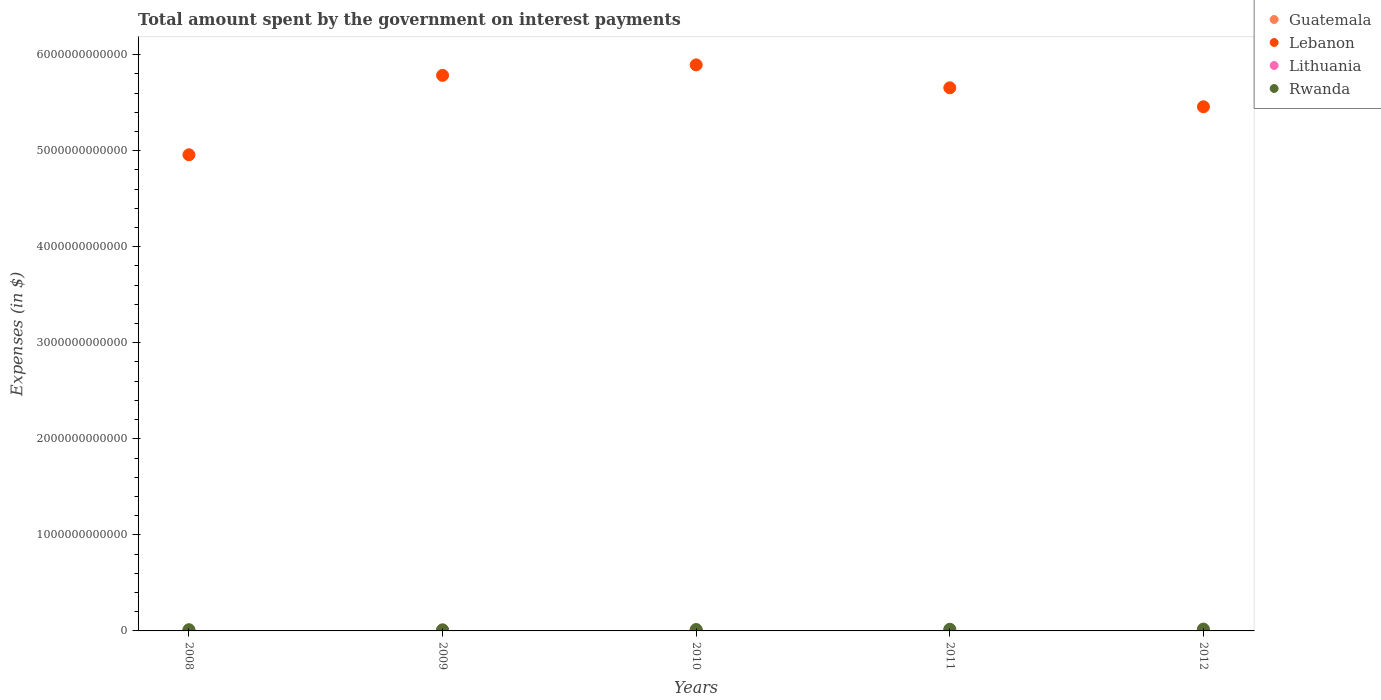How many different coloured dotlines are there?
Your response must be concise. 4. What is the amount spent on interest payments by the government in Guatemala in 2012?
Make the answer very short. 5.89e+09. Across all years, what is the maximum amount spent on interest payments by the government in Lebanon?
Provide a succinct answer. 5.89e+12. Across all years, what is the minimum amount spent on interest payments by the government in Lithuania?
Offer a terse response. 7.02e+08. In which year was the amount spent on interest payments by the government in Rwanda minimum?
Your response must be concise. 2009. What is the total amount spent on interest payments by the government in Lithuania in the graph?
Your response must be concise. 7.79e+09. What is the difference between the amount spent on interest payments by the government in Guatemala in 2010 and that in 2011?
Your answer should be compact. -5.17e+08. What is the difference between the amount spent on interest payments by the government in Guatemala in 2009 and the amount spent on interest payments by the government in Lebanon in 2010?
Your response must be concise. -5.89e+12. What is the average amount spent on interest payments by the government in Guatemala per year?
Offer a terse response. 4.87e+09. In the year 2011, what is the difference between the amount spent on interest payments by the government in Rwanda and amount spent on interest payments by the government in Lithuania?
Offer a very short reply. 1.53e+1. In how many years, is the amount spent on interest payments by the government in Rwanda greater than 3400000000000 $?
Provide a succinct answer. 0. What is the ratio of the amount spent on interest payments by the government in Lithuania in 2010 to that in 2012?
Make the answer very short. 0.83. Is the difference between the amount spent on interest payments by the government in Rwanda in 2008 and 2012 greater than the difference between the amount spent on interest payments by the government in Lithuania in 2008 and 2012?
Provide a short and direct response. No. What is the difference between the highest and the second highest amount spent on interest payments by the government in Rwanda?
Keep it short and to the point. 1.75e+09. What is the difference between the highest and the lowest amount spent on interest payments by the government in Lithuania?
Your answer should be compact. 1.46e+09. Is the sum of the amount spent on interest payments by the government in Rwanda in 2009 and 2011 greater than the maximum amount spent on interest payments by the government in Lithuania across all years?
Your answer should be very brief. Yes. Does the amount spent on interest payments by the government in Rwanda monotonically increase over the years?
Give a very brief answer. No. What is the difference between two consecutive major ticks on the Y-axis?
Your response must be concise. 1.00e+12. Does the graph contain grids?
Your response must be concise. No. How many legend labels are there?
Your response must be concise. 4. What is the title of the graph?
Your response must be concise. Total amount spent by the government on interest payments. What is the label or title of the X-axis?
Your answer should be compact. Years. What is the label or title of the Y-axis?
Your answer should be compact. Expenses (in $). What is the Expenses (in $) in Guatemala in 2008?
Your answer should be compact. 3.96e+09. What is the Expenses (in $) of Lebanon in 2008?
Your response must be concise. 4.96e+12. What is the Expenses (in $) in Lithuania in 2008?
Keep it short and to the point. 7.02e+08. What is the Expenses (in $) in Rwanda in 2008?
Make the answer very short. 1.26e+1. What is the Expenses (in $) of Guatemala in 2009?
Your answer should be compact. 4.30e+09. What is the Expenses (in $) in Lebanon in 2009?
Your response must be concise. 5.78e+12. What is the Expenses (in $) of Lithuania in 2009?
Provide a short and direct response. 1.13e+09. What is the Expenses (in $) of Rwanda in 2009?
Provide a short and direct response. 1.14e+1. What is the Expenses (in $) of Guatemala in 2010?
Ensure brevity in your answer.  4.83e+09. What is the Expenses (in $) in Lebanon in 2010?
Give a very brief answer. 5.89e+12. What is the Expenses (in $) of Lithuania in 2010?
Offer a very short reply. 1.79e+09. What is the Expenses (in $) of Rwanda in 2010?
Make the answer very short. 1.47e+1. What is the Expenses (in $) of Guatemala in 2011?
Provide a succinct answer. 5.35e+09. What is the Expenses (in $) of Lebanon in 2011?
Offer a terse response. 5.65e+12. What is the Expenses (in $) in Lithuania in 2011?
Your answer should be very brief. 2.01e+09. What is the Expenses (in $) in Rwanda in 2011?
Give a very brief answer. 1.74e+1. What is the Expenses (in $) of Guatemala in 2012?
Your answer should be compact. 5.89e+09. What is the Expenses (in $) of Lebanon in 2012?
Give a very brief answer. 5.46e+12. What is the Expenses (in $) of Lithuania in 2012?
Your answer should be very brief. 2.16e+09. What is the Expenses (in $) of Rwanda in 2012?
Your answer should be very brief. 1.91e+1. Across all years, what is the maximum Expenses (in $) in Guatemala?
Offer a very short reply. 5.89e+09. Across all years, what is the maximum Expenses (in $) in Lebanon?
Give a very brief answer. 5.89e+12. Across all years, what is the maximum Expenses (in $) in Lithuania?
Your response must be concise. 2.16e+09. Across all years, what is the maximum Expenses (in $) in Rwanda?
Your answer should be compact. 1.91e+1. Across all years, what is the minimum Expenses (in $) in Guatemala?
Make the answer very short. 3.96e+09. Across all years, what is the minimum Expenses (in $) in Lebanon?
Give a very brief answer. 4.96e+12. Across all years, what is the minimum Expenses (in $) of Lithuania?
Provide a succinct answer. 7.02e+08. Across all years, what is the minimum Expenses (in $) of Rwanda?
Your answer should be compact. 1.14e+1. What is the total Expenses (in $) in Guatemala in the graph?
Offer a very short reply. 2.43e+1. What is the total Expenses (in $) of Lebanon in the graph?
Offer a terse response. 2.77e+13. What is the total Expenses (in $) of Lithuania in the graph?
Your answer should be compact. 7.79e+09. What is the total Expenses (in $) in Rwanda in the graph?
Provide a short and direct response. 7.52e+1. What is the difference between the Expenses (in $) of Guatemala in 2008 and that in 2009?
Your answer should be compact. -3.34e+08. What is the difference between the Expenses (in $) of Lebanon in 2008 and that in 2009?
Offer a terse response. -8.27e+11. What is the difference between the Expenses (in $) in Lithuania in 2008 and that in 2009?
Your answer should be very brief. -4.26e+08. What is the difference between the Expenses (in $) of Rwanda in 2008 and that in 2009?
Provide a short and direct response. 1.20e+09. What is the difference between the Expenses (in $) in Guatemala in 2008 and that in 2010?
Ensure brevity in your answer.  -8.70e+08. What is the difference between the Expenses (in $) of Lebanon in 2008 and that in 2010?
Ensure brevity in your answer.  -9.36e+11. What is the difference between the Expenses (in $) of Lithuania in 2008 and that in 2010?
Make the answer very short. -1.09e+09. What is the difference between the Expenses (in $) in Rwanda in 2008 and that in 2010?
Provide a short and direct response. -2.06e+09. What is the difference between the Expenses (in $) of Guatemala in 2008 and that in 2011?
Your answer should be very brief. -1.39e+09. What is the difference between the Expenses (in $) in Lebanon in 2008 and that in 2011?
Your answer should be compact. -6.97e+11. What is the difference between the Expenses (in $) in Lithuania in 2008 and that in 2011?
Your response must be concise. -1.31e+09. What is the difference between the Expenses (in $) in Rwanda in 2008 and that in 2011?
Your answer should be compact. -4.74e+09. What is the difference between the Expenses (in $) in Guatemala in 2008 and that in 2012?
Your answer should be very brief. -1.93e+09. What is the difference between the Expenses (in $) in Lebanon in 2008 and that in 2012?
Your answer should be compact. -5.00e+11. What is the difference between the Expenses (in $) in Lithuania in 2008 and that in 2012?
Provide a short and direct response. -1.46e+09. What is the difference between the Expenses (in $) of Rwanda in 2008 and that in 2012?
Provide a short and direct response. -6.49e+09. What is the difference between the Expenses (in $) of Guatemala in 2009 and that in 2010?
Your response must be concise. -5.37e+08. What is the difference between the Expenses (in $) in Lebanon in 2009 and that in 2010?
Give a very brief answer. -1.09e+11. What is the difference between the Expenses (in $) in Lithuania in 2009 and that in 2010?
Give a very brief answer. -6.61e+08. What is the difference between the Expenses (in $) in Rwanda in 2009 and that in 2010?
Keep it short and to the point. -3.26e+09. What is the difference between the Expenses (in $) of Guatemala in 2009 and that in 2011?
Make the answer very short. -1.05e+09. What is the difference between the Expenses (in $) of Lebanon in 2009 and that in 2011?
Provide a succinct answer. 1.29e+11. What is the difference between the Expenses (in $) of Lithuania in 2009 and that in 2011?
Keep it short and to the point. -8.82e+08. What is the difference between the Expenses (in $) of Rwanda in 2009 and that in 2011?
Offer a very short reply. -5.94e+09. What is the difference between the Expenses (in $) in Guatemala in 2009 and that in 2012?
Your answer should be very brief. -1.60e+09. What is the difference between the Expenses (in $) of Lebanon in 2009 and that in 2012?
Your response must be concise. 3.27e+11. What is the difference between the Expenses (in $) of Lithuania in 2009 and that in 2012?
Your answer should be compact. -1.03e+09. What is the difference between the Expenses (in $) of Rwanda in 2009 and that in 2012?
Provide a short and direct response. -7.69e+09. What is the difference between the Expenses (in $) of Guatemala in 2010 and that in 2011?
Provide a short and direct response. -5.17e+08. What is the difference between the Expenses (in $) in Lebanon in 2010 and that in 2011?
Provide a short and direct response. 2.38e+11. What is the difference between the Expenses (in $) in Lithuania in 2010 and that in 2011?
Give a very brief answer. -2.20e+08. What is the difference between the Expenses (in $) in Rwanda in 2010 and that in 2011?
Offer a very short reply. -2.68e+09. What is the difference between the Expenses (in $) in Guatemala in 2010 and that in 2012?
Offer a very short reply. -1.06e+09. What is the difference between the Expenses (in $) of Lebanon in 2010 and that in 2012?
Keep it short and to the point. 4.36e+11. What is the difference between the Expenses (in $) in Lithuania in 2010 and that in 2012?
Provide a succinct answer. -3.69e+08. What is the difference between the Expenses (in $) of Rwanda in 2010 and that in 2012?
Your answer should be compact. -4.42e+09. What is the difference between the Expenses (in $) of Guatemala in 2011 and that in 2012?
Make the answer very short. -5.45e+08. What is the difference between the Expenses (in $) of Lebanon in 2011 and that in 2012?
Offer a very short reply. 1.98e+11. What is the difference between the Expenses (in $) of Lithuania in 2011 and that in 2012?
Offer a terse response. -1.48e+08. What is the difference between the Expenses (in $) in Rwanda in 2011 and that in 2012?
Provide a short and direct response. -1.75e+09. What is the difference between the Expenses (in $) in Guatemala in 2008 and the Expenses (in $) in Lebanon in 2009?
Your answer should be very brief. -5.78e+12. What is the difference between the Expenses (in $) in Guatemala in 2008 and the Expenses (in $) in Lithuania in 2009?
Give a very brief answer. 2.83e+09. What is the difference between the Expenses (in $) in Guatemala in 2008 and the Expenses (in $) in Rwanda in 2009?
Offer a very short reply. -7.45e+09. What is the difference between the Expenses (in $) in Lebanon in 2008 and the Expenses (in $) in Lithuania in 2009?
Offer a very short reply. 4.96e+12. What is the difference between the Expenses (in $) of Lebanon in 2008 and the Expenses (in $) of Rwanda in 2009?
Give a very brief answer. 4.95e+12. What is the difference between the Expenses (in $) in Lithuania in 2008 and the Expenses (in $) in Rwanda in 2009?
Give a very brief answer. -1.07e+1. What is the difference between the Expenses (in $) of Guatemala in 2008 and the Expenses (in $) of Lebanon in 2010?
Ensure brevity in your answer.  -5.89e+12. What is the difference between the Expenses (in $) in Guatemala in 2008 and the Expenses (in $) in Lithuania in 2010?
Your answer should be very brief. 2.17e+09. What is the difference between the Expenses (in $) of Guatemala in 2008 and the Expenses (in $) of Rwanda in 2010?
Your answer should be very brief. -1.07e+1. What is the difference between the Expenses (in $) of Lebanon in 2008 and the Expenses (in $) of Lithuania in 2010?
Offer a terse response. 4.96e+12. What is the difference between the Expenses (in $) in Lebanon in 2008 and the Expenses (in $) in Rwanda in 2010?
Ensure brevity in your answer.  4.94e+12. What is the difference between the Expenses (in $) in Lithuania in 2008 and the Expenses (in $) in Rwanda in 2010?
Give a very brief answer. -1.40e+1. What is the difference between the Expenses (in $) in Guatemala in 2008 and the Expenses (in $) in Lebanon in 2011?
Your answer should be compact. -5.65e+12. What is the difference between the Expenses (in $) in Guatemala in 2008 and the Expenses (in $) in Lithuania in 2011?
Your answer should be very brief. 1.95e+09. What is the difference between the Expenses (in $) in Guatemala in 2008 and the Expenses (in $) in Rwanda in 2011?
Your answer should be very brief. -1.34e+1. What is the difference between the Expenses (in $) of Lebanon in 2008 and the Expenses (in $) of Lithuania in 2011?
Your answer should be very brief. 4.96e+12. What is the difference between the Expenses (in $) in Lebanon in 2008 and the Expenses (in $) in Rwanda in 2011?
Your response must be concise. 4.94e+12. What is the difference between the Expenses (in $) of Lithuania in 2008 and the Expenses (in $) of Rwanda in 2011?
Offer a very short reply. -1.66e+1. What is the difference between the Expenses (in $) of Guatemala in 2008 and the Expenses (in $) of Lebanon in 2012?
Your answer should be very brief. -5.45e+12. What is the difference between the Expenses (in $) in Guatemala in 2008 and the Expenses (in $) in Lithuania in 2012?
Your response must be concise. 1.80e+09. What is the difference between the Expenses (in $) of Guatemala in 2008 and the Expenses (in $) of Rwanda in 2012?
Keep it short and to the point. -1.51e+1. What is the difference between the Expenses (in $) of Lebanon in 2008 and the Expenses (in $) of Lithuania in 2012?
Offer a terse response. 4.96e+12. What is the difference between the Expenses (in $) of Lebanon in 2008 and the Expenses (in $) of Rwanda in 2012?
Provide a succinct answer. 4.94e+12. What is the difference between the Expenses (in $) in Lithuania in 2008 and the Expenses (in $) in Rwanda in 2012?
Provide a succinct answer. -1.84e+1. What is the difference between the Expenses (in $) in Guatemala in 2009 and the Expenses (in $) in Lebanon in 2010?
Your answer should be very brief. -5.89e+12. What is the difference between the Expenses (in $) in Guatemala in 2009 and the Expenses (in $) in Lithuania in 2010?
Give a very brief answer. 2.51e+09. What is the difference between the Expenses (in $) in Guatemala in 2009 and the Expenses (in $) in Rwanda in 2010?
Offer a terse response. -1.04e+1. What is the difference between the Expenses (in $) in Lebanon in 2009 and the Expenses (in $) in Lithuania in 2010?
Provide a succinct answer. 5.78e+12. What is the difference between the Expenses (in $) of Lebanon in 2009 and the Expenses (in $) of Rwanda in 2010?
Give a very brief answer. 5.77e+12. What is the difference between the Expenses (in $) in Lithuania in 2009 and the Expenses (in $) in Rwanda in 2010?
Give a very brief answer. -1.35e+1. What is the difference between the Expenses (in $) of Guatemala in 2009 and the Expenses (in $) of Lebanon in 2011?
Your answer should be very brief. -5.65e+12. What is the difference between the Expenses (in $) of Guatemala in 2009 and the Expenses (in $) of Lithuania in 2011?
Your answer should be very brief. 2.29e+09. What is the difference between the Expenses (in $) of Guatemala in 2009 and the Expenses (in $) of Rwanda in 2011?
Give a very brief answer. -1.31e+1. What is the difference between the Expenses (in $) of Lebanon in 2009 and the Expenses (in $) of Lithuania in 2011?
Ensure brevity in your answer.  5.78e+12. What is the difference between the Expenses (in $) in Lebanon in 2009 and the Expenses (in $) in Rwanda in 2011?
Provide a succinct answer. 5.77e+12. What is the difference between the Expenses (in $) of Lithuania in 2009 and the Expenses (in $) of Rwanda in 2011?
Offer a terse response. -1.62e+1. What is the difference between the Expenses (in $) in Guatemala in 2009 and the Expenses (in $) in Lebanon in 2012?
Offer a terse response. -5.45e+12. What is the difference between the Expenses (in $) of Guatemala in 2009 and the Expenses (in $) of Lithuania in 2012?
Offer a very short reply. 2.14e+09. What is the difference between the Expenses (in $) in Guatemala in 2009 and the Expenses (in $) in Rwanda in 2012?
Offer a very short reply. -1.48e+1. What is the difference between the Expenses (in $) of Lebanon in 2009 and the Expenses (in $) of Lithuania in 2012?
Ensure brevity in your answer.  5.78e+12. What is the difference between the Expenses (in $) in Lebanon in 2009 and the Expenses (in $) in Rwanda in 2012?
Ensure brevity in your answer.  5.76e+12. What is the difference between the Expenses (in $) of Lithuania in 2009 and the Expenses (in $) of Rwanda in 2012?
Your answer should be very brief. -1.80e+1. What is the difference between the Expenses (in $) in Guatemala in 2010 and the Expenses (in $) in Lebanon in 2011?
Offer a very short reply. -5.65e+12. What is the difference between the Expenses (in $) in Guatemala in 2010 and the Expenses (in $) in Lithuania in 2011?
Make the answer very short. 2.82e+09. What is the difference between the Expenses (in $) of Guatemala in 2010 and the Expenses (in $) of Rwanda in 2011?
Give a very brief answer. -1.25e+1. What is the difference between the Expenses (in $) of Lebanon in 2010 and the Expenses (in $) of Lithuania in 2011?
Provide a succinct answer. 5.89e+12. What is the difference between the Expenses (in $) in Lebanon in 2010 and the Expenses (in $) in Rwanda in 2011?
Make the answer very short. 5.88e+12. What is the difference between the Expenses (in $) in Lithuania in 2010 and the Expenses (in $) in Rwanda in 2011?
Offer a terse response. -1.56e+1. What is the difference between the Expenses (in $) in Guatemala in 2010 and the Expenses (in $) in Lebanon in 2012?
Offer a very short reply. -5.45e+12. What is the difference between the Expenses (in $) in Guatemala in 2010 and the Expenses (in $) in Lithuania in 2012?
Make the answer very short. 2.67e+09. What is the difference between the Expenses (in $) of Guatemala in 2010 and the Expenses (in $) of Rwanda in 2012?
Make the answer very short. -1.43e+1. What is the difference between the Expenses (in $) in Lebanon in 2010 and the Expenses (in $) in Lithuania in 2012?
Make the answer very short. 5.89e+12. What is the difference between the Expenses (in $) of Lebanon in 2010 and the Expenses (in $) of Rwanda in 2012?
Offer a very short reply. 5.87e+12. What is the difference between the Expenses (in $) in Lithuania in 2010 and the Expenses (in $) in Rwanda in 2012?
Your answer should be very brief. -1.73e+1. What is the difference between the Expenses (in $) of Guatemala in 2011 and the Expenses (in $) of Lebanon in 2012?
Your answer should be very brief. -5.45e+12. What is the difference between the Expenses (in $) of Guatemala in 2011 and the Expenses (in $) of Lithuania in 2012?
Your response must be concise. 3.19e+09. What is the difference between the Expenses (in $) in Guatemala in 2011 and the Expenses (in $) in Rwanda in 2012?
Ensure brevity in your answer.  -1.38e+1. What is the difference between the Expenses (in $) in Lebanon in 2011 and the Expenses (in $) in Lithuania in 2012?
Your answer should be compact. 5.65e+12. What is the difference between the Expenses (in $) of Lebanon in 2011 and the Expenses (in $) of Rwanda in 2012?
Ensure brevity in your answer.  5.64e+12. What is the difference between the Expenses (in $) of Lithuania in 2011 and the Expenses (in $) of Rwanda in 2012?
Offer a very short reply. -1.71e+1. What is the average Expenses (in $) of Guatemala per year?
Ensure brevity in your answer.  4.87e+09. What is the average Expenses (in $) in Lebanon per year?
Make the answer very short. 5.55e+12. What is the average Expenses (in $) in Lithuania per year?
Your response must be concise. 1.56e+09. What is the average Expenses (in $) in Rwanda per year?
Provide a short and direct response. 1.50e+1. In the year 2008, what is the difference between the Expenses (in $) in Guatemala and Expenses (in $) in Lebanon?
Make the answer very short. -4.95e+12. In the year 2008, what is the difference between the Expenses (in $) in Guatemala and Expenses (in $) in Lithuania?
Your answer should be compact. 3.26e+09. In the year 2008, what is the difference between the Expenses (in $) of Guatemala and Expenses (in $) of Rwanda?
Offer a terse response. -8.65e+09. In the year 2008, what is the difference between the Expenses (in $) in Lebanon and Expenses (in $) in Lithuania?
Make the answer very short. 4.96e+12. In the year 2008, what is the difference between the Expenses (in $) of Lebanon and Expenses (in $) of Rwanda?
Give a very brief answer. 4.94e+12. In the year 2008, what is the difference between the Expenses (in $) of Lithuania and Expenses (in $) of Rwanda?
Your answer should be compact. -1.19e+1. In the year 2009, what is the difference between the Expenses (in $) in Guatemala and Expenses (in $) in Lebanon?
Offer a terse response. -5.78e+12. In the year 2009, what is the difference between the Expenses (in $) in Guatemala and Expenses (in $) in Lithuania?
Your answer should be compact. 3.17e+09. In the year 2009, what is the difference between the Expenses (in $) in Guatemala and Expenses (in $) in Rwanda?
Offer a very short reply. -7.12e+09. In the year 2009, what is the difference between the Expenses (in $) of Lebanon and Expenses (in $) of Lithuania?
Your answer should be very brief. 5.78e+12. In the year 2009, what is the difference between the Expenses (in $) of Lebanon and Expenses (in $) of Rwanda?
Provide a succinct answer. 5.77e+12. In the year 2009, what is the difference between the Expenses (in $) of Lithuania and Expenses (in $) of Rwanda?
Provide a short and direct response. -1.03e+1. In the year 2010, what is the difference between the Expenses (in $) of Guatemala and Expenses (in $) of Lebanon?
Provide a short and direct response. -5.89e+12. In the year 2010, what is the difference between the Expenses (in $) in Guatemala and Expenses (in $) in Lithuania?
Provide a succinct answer. 3.04e+09. In the year 2010, what is the difference between the Expenses (in $) of Guatemala and Expenses (in $) of Rwanda?
Your response must be concise. -9.84e+09. In the year 2010, what is the difference between the Expenses (in $) in Lebanon and Expenses (in $) in Lithuania?
Your answer should be very brief. 5.89e+12. In the year 2010, what is the difference between the Expenses (in $) of Lebanon and Expenses (in $) of Rwanda?
Ensure brevity in your answer.  5.88e+12. In the year 2010, what is the difference between the Expenses (in $) in Lithuania and Expenses (in $) in Rwanda?
Your answer should be very brief. -1.29e+1. In the year 2011, what is the difference between the Expenses (in $) of Guatemala and Expenses (in $) of Lebanon?
Give a very brief answer. -5.65e+12. In the year 2011, what is the difference between the Expenses (in $) of Guatemala and Expenses (in $) of Lithuania?
Make the answer very short. 3.34e+09. In the year 2011, what is the difference between the Expenses (in $) of Guatemala and Expenses (in $) of Rwanda?
Ensure brevity in your answer.  -1.20e+1. In the year 2011, what is the difference between the Expenses (in $) of Lebanon and Expenses (in $) of Lithuania?
Provide a short and direct response. 5.65e+12. In the year 2011, what is the difference between the Expenses (in $) of Lebanon and Expenses (in $) of Rwanda?
Keep it short and to the point. 5.64e+12. In the year 2011, what is the difference between the Expenses (in $) in Lithuania and Expenses (in $) in Rwanda?
Provide a succinct answer. -1.53e+1. In the year 2012, what is the difference between the Expenses (in $) of Guatemala and Expenses (in $) of Lebanon?
Your answer should be compact. -5.45e+12. In the year 2012, what is the difference between the Expenses (in $) of Guatemala and Expenses (in $) of Lithuania?
Offer a very short reply. 3.74e+09. In the year 2012, what is the difference between the Expenses (in $) in Guatemala and Expenses (in $) in Rwanda?
Offer a very short reply. -1.32e+1. In the year 2012, what is the difference between the Expenses (in $) in Lebanon and Expenses (in $) in Lithuania?
Keep it short and to the point. 5.45e+12. In the year 2012, what is the difference between the Expenses (in $) in Lebanon and Expenses (in $) in Rwanda?
Offer a terse response. 5.44e+12. In the year 2012, what is the difference between the Expenses (in $) of Lithuania and Expenses (in $) of Rwanda?
Provide a short and direct response. -1.69e+1. What is the ratio of the Expenses (in $) of Guatemala in 2008 to that in 2009?
Your answer should be compact. 0.92. What is the ratio of the Expenses (in $) of Lithuania in 2008 to that in 2009?
Offer a terse response. 0.62. What is the ratio of the Expenses (in $) in Rwanda in 2008 to that in 2009?
Offer a terse response. 1.11. What is the ratio of the Expenses (in $) of Guatemala in 2008 to that in 2010?
Your answer should be compact. 0.82. What is the ratio of the Expenses (in $) in Lebanon in 2008 to that in 2010?
Your response must be concise. 0.84. What is the ratio of the Expenses (in $) of Lithuania in 2008 to that in 2010?
Ensure brevity in your answer.  0.39. What is the ratio of the Expenses (in $) in Rwanda in 2008 to that in 2010?
Keep it short and to the point. 0.86. What is the ratio of the Expenses (in $) of Guatemala in 2008 to that in 2011?
Your answer should be very brief. 0.74. What is the ratio of the Expenses (in $) in Lebanon in 2008 to that in 2011?
Make the answer very short. 0.88. What is the ratio of the Expenses (in $) of Lithuania in 2008 to that in 2011?
Provide a short and direct response. 0.35. What is the ratio of the Expenses (in $) of Rwanda in 2008 to that in 2011?
Ensure brevity in your answer.  0.73. What is the ratio of the Expenses (in $) in Guatemala in 2008 to that in 2012?
Your answer should be compact. 0.67. What is the ratio of the Expenses (in $) in Lebanon in 2008 to that in 2012?
Your answer should be very brief. 0.91. What is the ratio of the Expenses (in $) of Lithuania in 2008 to that in 2012?
Your answer should be very brief. 0.33. What is the ratio of the Expenses (in $) in Rwanda in 2008 to that in 2012?
Keep it short and to the point. 0.66. What is the ratio of the Expenses (in $) of Guatemala in 2009 to that in 2010?
Your response must be concise. 0.89. What is the ratio of the Expenses (in $) of Lebanon in 2009 to that in 2010?
Ensure brevity in your answer.  0.98. What is the ratio of the Expenses (in $) in Lithuania in 2009 to that in 2010?
Your answer should be very brief. 0.63. What is the ratio of the Expenses (in $) of Rwanda in 2009 to that in 2010?
Offer a terse response. 0.78. What is the ratio of the Expenses (in $) in Guatemala in 2009 to that in 2011?
Give a very brief answer. 0.8. What is the ratio of the Expenses (in $) in Lebanon in 2009 to that in 2011?
Your answer should be very brief. 1.02. What is the ratio of the Expenses (in $) of Lithuania in 2009 to that in 2011?
Give a very brief answer. 0.56. What is the ratio of the Expenses (in $) in Rwanda in 2009 to that in 2011?
Keep it short and to the point. 0.66. What is the ratio of the Expenses (in $) of Guatemala in 2009 to that in 2012?
Provide a succinct answer. 0.73. What is the ratio of the Expenses (in $) in Lebanon in 2009 to that in 2012?
Provide a succinct answer. 1.06. What is the ratio of the Expenses (in $) of Lithuania in 2009 to that in 2012?
Give a very brief answer. 0.52. What is the ratio of the Expenses (in $) in Rwanda in 2009 to that in 2012?
Give a very brief answer. 0.6. What is the ratio of the Expenses (in $) of Guatemala in 2010 to that in 2011?
Offer a very short reply. 0.9. What is the ratio of the Expenses (in $) in Lebanon in 2010 to that in 2011?
Give a very brief answer. 1.04. What is the ratio of the Expenses (in $) of Lithuania in 2010 to that in 2011?
Your response must be concise. 0.89. What is the ratio of the Expenses (in $) of Rwanda in 2010 to that in 2011?
Your answer should be compact. 0.85. What is the ratio of the Expenses (in $) in Guatemala in 2010 to that in 2012?
Provide a short and direct response. 0.82. What is the ratio of the Expenses (in $) in Lebanon in 2010 to that in 2012?
Offer a terse response. 1.08. What is the ratio of the Expenses (in $) in Lithuania in 2010 to that in 2012?
Offer a very short reply. 0.83. What is the ratio of the Expenses (in $) in Rwanda in 2010 to that in 2012?
Your answer should be compact. 0.77. What is the ratio of the Expenses (in $) in Guatemala in 2011 to that in 2012?
Your answer should be compact. 0.91. What is the ratio of the Expenses (in $) in Lebanon in 2011 to that in 2012?
Offer a terse response. 1.04. What is the ratio of the Expenses (in $) in Lithuania in 2011 to that in 2012?
Ensure brevity in your answer.  0.93. What is the ratio of the Expenses (in $) in Rwanda in 2011 to that in 2012?
Give a very brief answer. 0.91. What is the difference between the highest and the second highest Expenses (in $) in Guatemala?
Your answer should be very brief. 5.45e+08. What is the difference between the highest and the second highest Expenses (in $) of Lebanon?
Provide a short and direct response. 1.09e+11. What is the difference between the highest and the second highest Expenses (in $) of Lithuania?
Provide a succinct answer. 1.48e+08. What is the difference between the highest and the second highest Expenses (in $) of Rwanda?
Your answer should be very brief. 1.75e+09. What is the difference between the highest and the lowest Expenses (in $) of Guatemala?
Your answer should be very brief. 1.93e+09. What is the difference between the highest and the lowest Expenses (in $) in Lebanon?
Provide a succinct answer. 9.36e+11. What is the difference between the highest and the lowest Expenses (in $) in Lithuania?
Make the answer very short. 1.46e+09. What is the difference between the highest and the lowest Expenses (in $) of Rwanda?
Ensure brevity in your answer.  7.69e+09. 